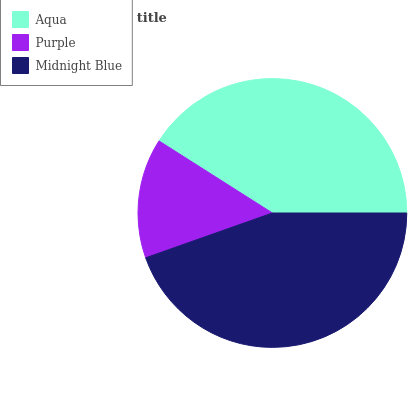Is Purple the minimum?
Answer yes or no. Yes. Is Midnight Blue the maximum?
Answer yes or no. Yes. Is Midnight Blue the minimum?
Answer yes or no. No. Is Purple the maximum?
Answer yes or no. No. Is Midnight Blue greater than Purple?
Answer yes or no. Yes. Is Purple less than Midnight Blue?
Answer yes or no. Yes. Is Purple greater than Midnight Blue?
Answer yes or no. No. Is Midnight Blue less than Purple?
Answer yes or no. No. Is Aqua the high median?
Answer yes or no. Yes. Is Aqua the low median?
Answer yes or no. Yes. Is Purple the high median?
Answer yes or no. No. Is Purple the low median?
Answer yes or no. No. 